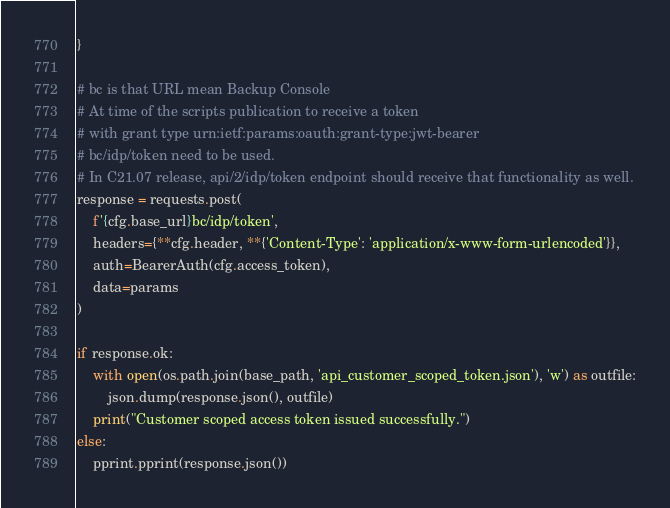Convert code to text. <code><loc_0><loc_0><loc_500><loc_500><_Python_>}

# bc is that URL mean Backup Console
# At time of the scripts publication to receive a token
# with grant type urn:ietf:params:oauth:grant-type:jwt-bearer
# bc/idp/token need to be used.
# In C21.07 release, api/2/idp/token endpoint should receive that functionality as well.
response = requests.post(
    f'{cfg.base_url}bc/idp/token',
    headers={**cfg.header, **{'Content-Type': 'application/x-www-form-urlencoded'}},
    auth=BearerAuth(cfg.access_token),
    data=params
)

if response.ok:
    with open(os.path.join(base_path, 'api_customer_scoped_token.json'), 'w') as outfile:
        json.dump(response.json(), outfile)
    print("Customer scoped access token issued successfully.")
else:
    pprint.pprint(response.json())
</code> 